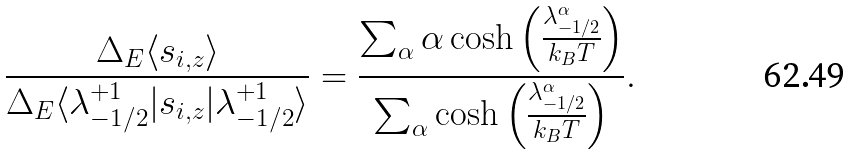<formula> <loc_0><loc_0><loc_500><loc_500>\frac { \Delta _ { E } \langle s _ { i , z } \rangle } { \Delta _ { E } \langle \lambda ^ { + 1 } _ { - 1 / 2 } | s _ { i , z } | \lambda ^ { + 1 } _ { - 1 / 2 } \rangle } = \frac { \sum _ { \alpha } \alpha \cosh \left ( \frac { \lambda ^ { \alpha } _ { - 1 / 2 } } { k _ { B } T } \right ) } { \sum _ { \alpha } \cosh \left ( \frac { \lambda ^ { \alpha } _ { - 1 / 2 } } { k _ { B } T } \right ) } .</formula> 